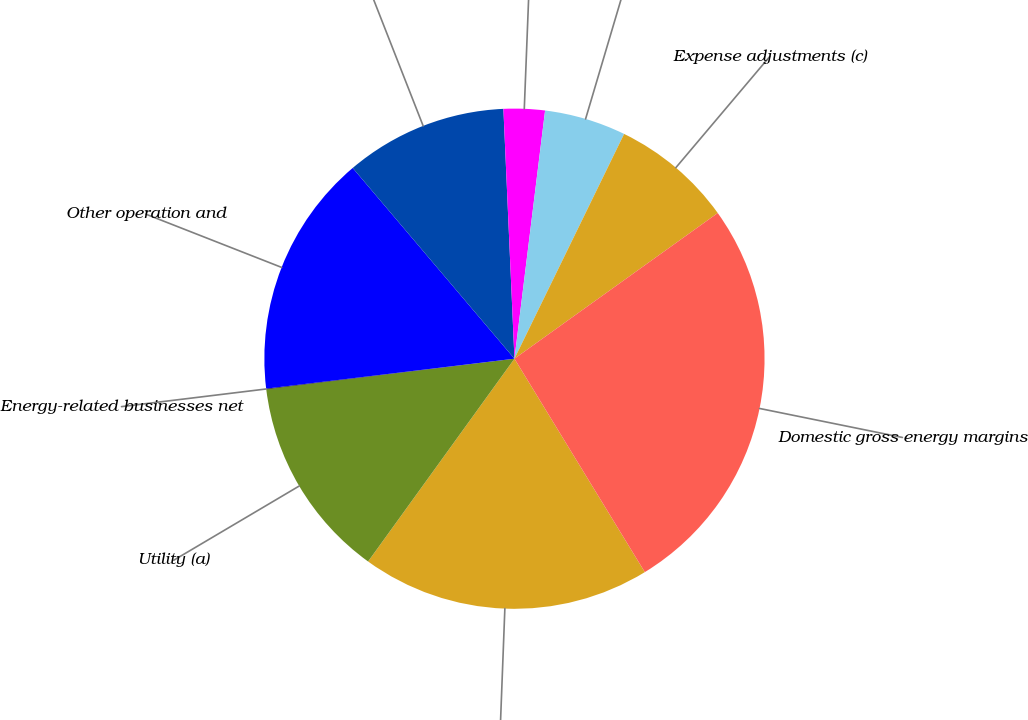Convert chart to OTSL. <chart><loc_0><loc_0><loc_500><loc_500><pie_chart><fcel>Operating Income (a)<fcel>Utility (a)<fcel>Energy-related businesses net<fcel>Other operation and<fcel>Depreciation (a)<fcel>Taxes other than income (a)<fcel>Revenue adjustments (c)<fcel>Expense adjustments (c)<fcel>Domestic gross energy margins<nl><fcel>18.68%<fcel>13.1%<fcel>0.04%<fcel>15.72%<fcel>10.49%<fcel>2.66%<fcel>5.27%<fcel>7.88%<fcel>26.17%<nl></chart> 